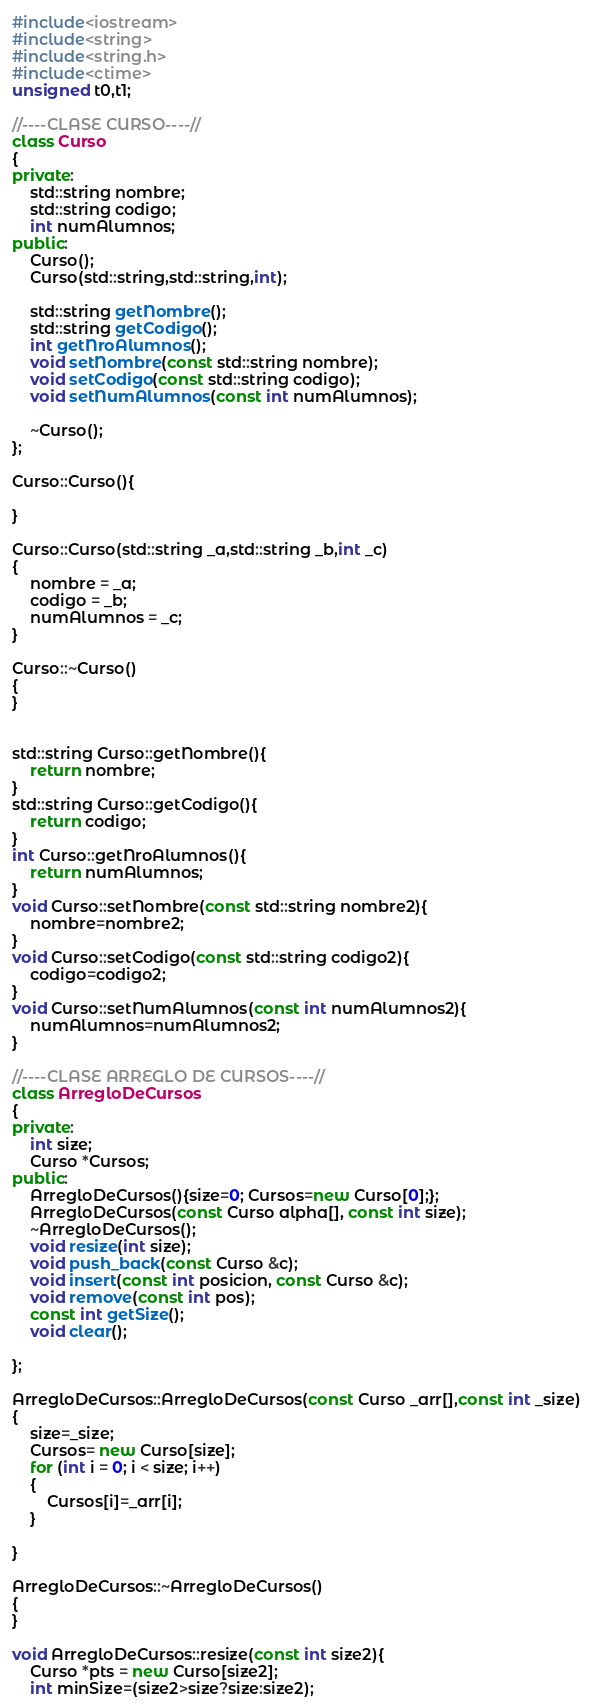Convert code to text. <code><loc_0><loc_0><loc_500><loc_500><_C++_>#include<iostream>
#include<string>
#include<string.h>
#include<ctime>
unsigned t0,t1;

//----CLASE CURSO----//
class Curso
{
private:
    std::string nombre;
    std::string codigo;
    int numAlumnos;
public:
    Curso();
    Curso(std::string,std::string,int);

    std::string getNombre();
    std::string getCodigo();
    int getNroAlumnos();
    void setNombre(const std::string nombre);
    void setCodigo(const std::string codigo);
    void setNumAlumnos(const int numAlumnos);

    ~Curso();
};

Curso::Curso(){

}

Curso::Curso(std::string _a,std::string _b,int _c)
{
    nombre = _a;
    codigo = _b;
    numAlumnos = _c;
}

Curso::~Curso()
{
}


std::string Curso::getNombre(){
    return nombre;
}
std::string Curso::getCodigo(){
    return codigo;
}
int Curso::getNroAlumnos(){
    return numAlumnos;
}
void Curso::setNombre(const std::string nombre2){
    nombre=nombre2;
}   
void Curso::setCodigo(const std::string codigo2){
    codigo=codigo2;
}
void Curso::setNumAlumnos(const int numAlumnos2){
    numAlumnos=numAlumnos2;
}

//----CLASE ARREGLO DE CURSOS----//
class ArregloDeCursos
{
private:
    int size;
    Curso *Cursos;
public:
    ArregloDeCursos(){size=0; Cursos=new Curso[0];};
    ArregloDeCursos(const Curso alpha[], const int size);
    ~ArregloDeCursos();
    void resize(int size);
    void push_back(const Curso &c);
    void insert(const int posicion, const Curso &c);
    void remove(const int pos);
    const int getSize();
    void clear();

};

ArregloDeCursos::ArregloDeCursos(const Curso _arr[],const int _size)
{
    size=_size;
    Cursos= new Curso[size];
    for (int i = 0; i < size; i++)
    {
        Cursos[i]=_arr[i];
    }
    
}

ArregloDeCursos::~ArregloDeCursos()
{
}

void ArregloDeCursos::resize(const int size2){
    Curso *pts = new Curso[size2];
    int minSize=(size2>size?size:size2);
</code> 